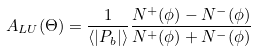Convert formula to latex. <formula><loc_0><loc_0><loc_500><loc_500>A _ { L U } ( \Theta ) = \frac { 1 } { \langle | P _ { b } | \rangle } \frac { N ^ { + } ( \phi ) - N ^ { - } ( \phi ) } { N ^ { + } ( \phi ) + N ^ { - } ( \phi ) }</formula> 